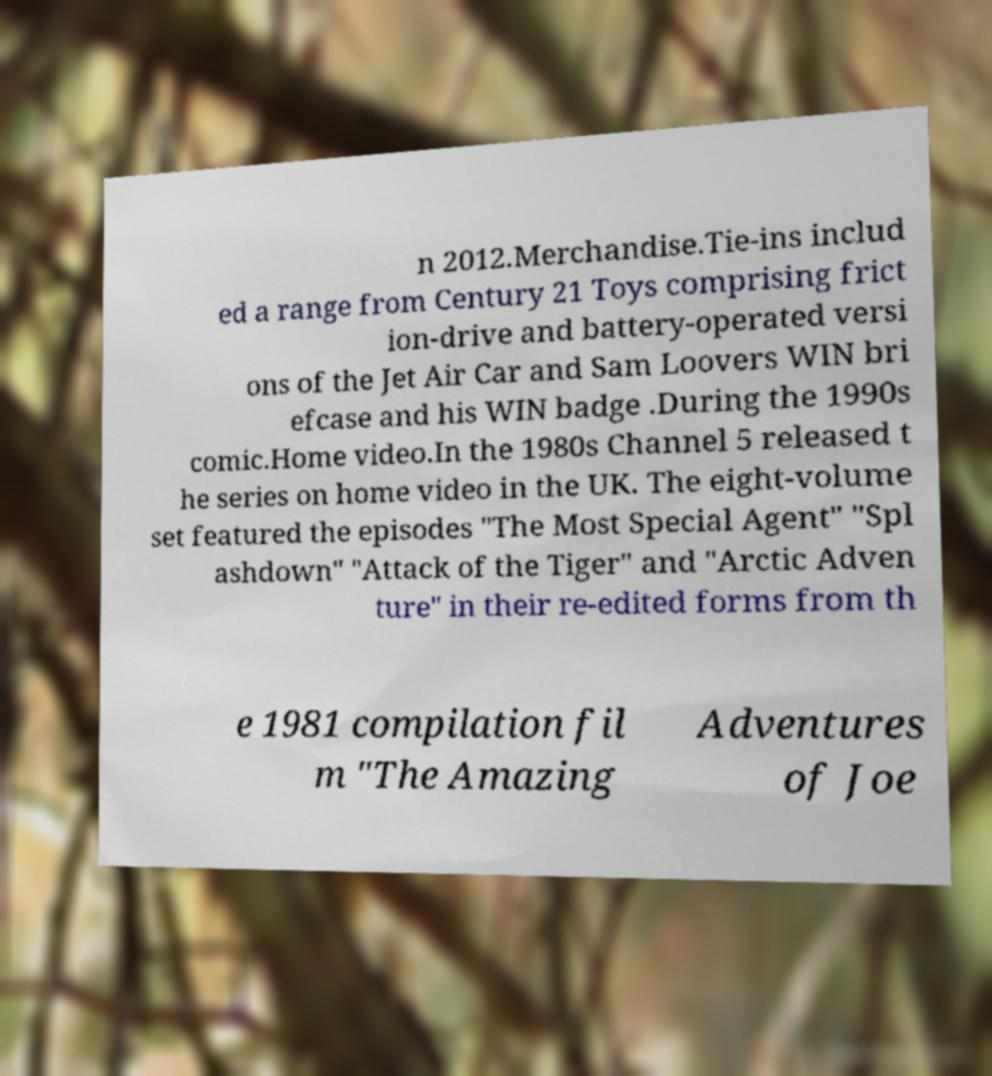What messages or text are displayed in this image? I need them in a readable, typed format. n 2012.Merchandise.Tie-ins includ ed a range from Century 21 Toys comprising frict ion-drive and battery-operated versi ons of the Jet Air Car and Sam Loovers WIN bri efcase and his WIN badge .During the 1990s comic.Home video.In the 1980s Channel 5 released t he series on home video in the UK. The eight-volume set featured the episodes "The Most Special Agent" "Spl ashdown" "Attack of the Tiger" and "Arctic Adven ture" in their re-edited forms from th e 1981 compilation fil m "The Amazing Adventures of Joe 